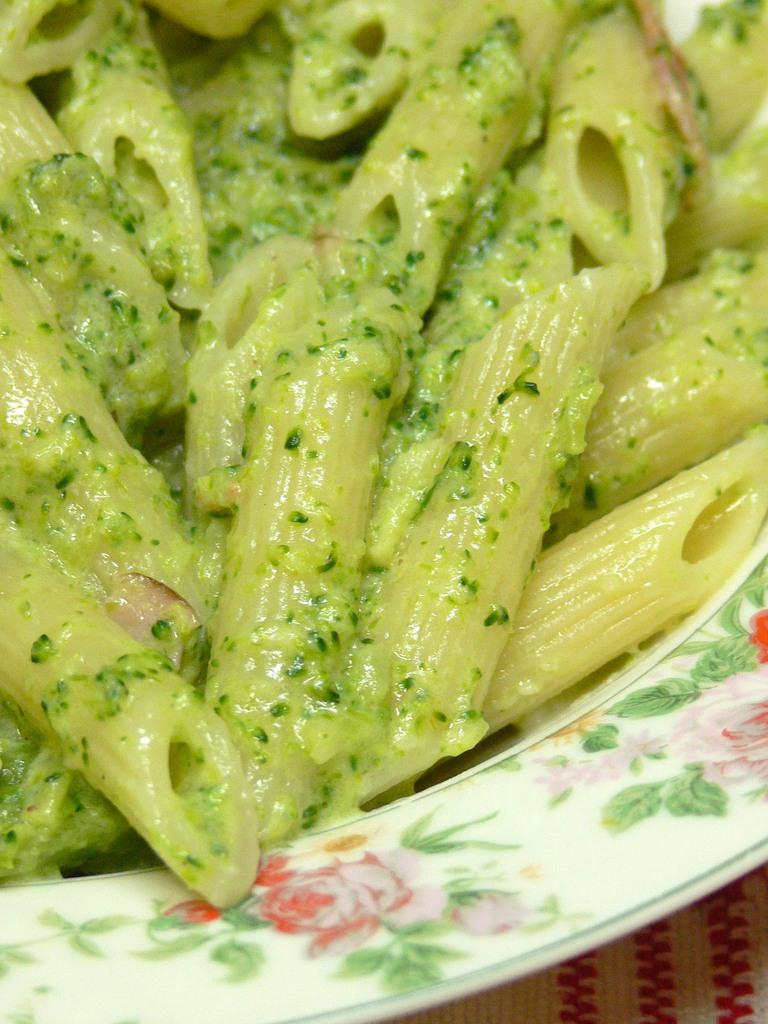What type of food is visible in the image? There is pasta in the image. How is the pasta presented? The pasta is in a white plate. Where is the plate with pasta located? The plate is kept on a table. What type of gate can be seen in the image? There is no gate present in the image; it features pasta in a white plate on a table. 